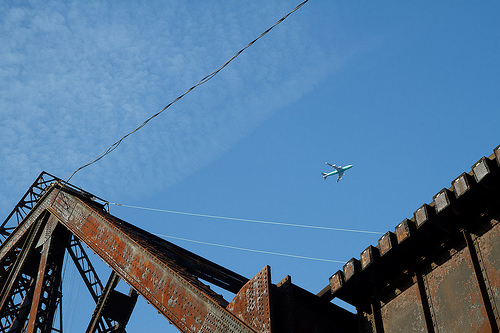Imagine you are standing on the bridge. What might you see? If you were standing on the bridge, you'd likely see a vast expanse of the blue sky overhead, with occasional aircraft passing by. Beneath the bridge, perhaps you might see a river or a busy roadway, depending on its location. The metallic aroma of the old steel would be palpable, adding to the sense of nostalgia. What's at the top of the bridge? At the top of the bridge, you might find more intricate and/or damaged beams, perhaps some old bolts and rivets holding them together. There might be a view of the land stretching out around you, revealing a mix of natural and urban landscapes. What kind of aircraft is in the sky? Can you elaborate? The aircraft in the sky appears to be a commercial airliner, possibly a Boeing or Airbus model given its size and shape. It's likely cruising at an altitude of around 30,000 feet, carrying passengers to their destinations across the country or even internationally. The sunlight glinting off its metallic body gives it a majestic appearance against the blue sky. 